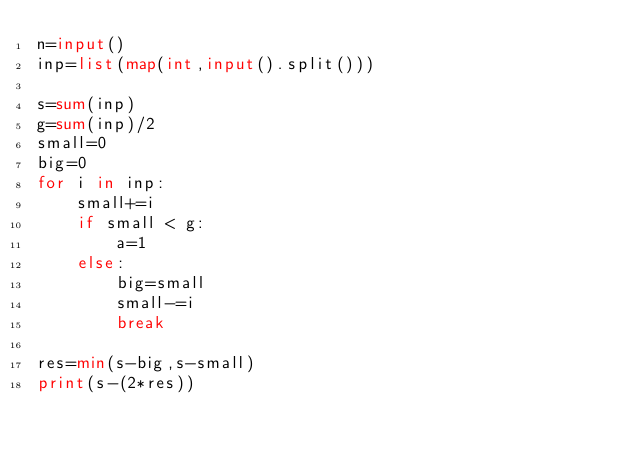Convert code to text. <code><loc_0><loc_0><loc_500><loc_500><_Python_>n=input()
inp=list(map(int,input().split()))

s=sum(inp)
g=sum(inp)/2
small=0
big=0
for i in inp:
    small+=i
    if small < g:
        a=1
    else:
        big=small
        small-=i
        break

res=min(s-big,s-small)
print(s-(2*res))</code> 